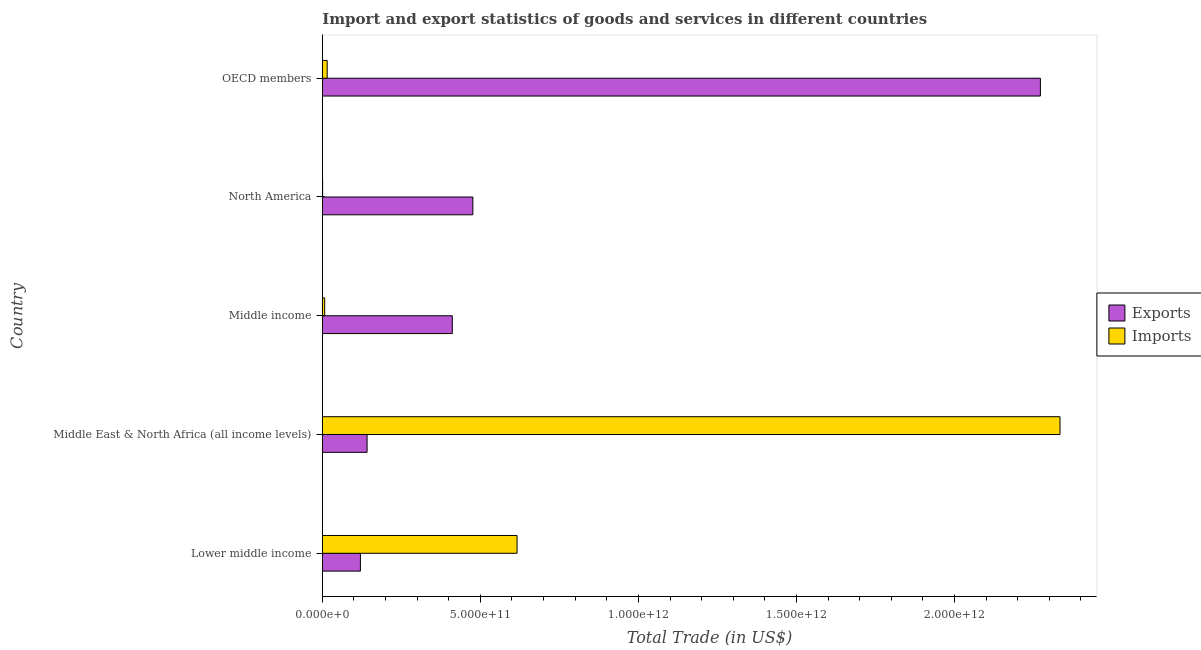How many groups of bars are there?
Give a very brief answer. 5. Are the number of bars per tick equal to the number of legend labels?
Offer a very short reply. Yes. Are the number of bars on each tick of the Y-axis equal?
Offer a terse response. Yes. How many bars are there on the 2nd tick from the top?
Ensure brevity in your answer.  2. What is the label of the 4th group of bars from the top?
Give a very brief answer. Middle East & North Africa (all income levels). In how many cases, is the number of bars for a given country not equal to the number of legend labels?
Provide a short and direct response. 0. What is the export of goods and services in Lower middle income?
Offer a very short reply. 1.20e+11. Across all countries, what is the maximum export of goods and services?
Offer a terse response. 2.27e+12. Across all countries, what is the minimum export of goods and services?
Provide a short and direct response. 1.20e+11. In which country was the export of goods and services maximum?
Provide a short and direct response. OECD members. What is the total imports of goods and services in the graph?
Offer a terse response. 2.97e+12. What is the difference between the imports of goods and services in Middle East & North Africa (all income levels) and that in OECD members?
Give a very brief answer. 2.32e+12. What is the difference between the imports of goods and services in OECD members and the export of goods and services in North America?
Give a very brief answer. -4.61e+11. What is the average export of goods and services per country?
Provide a succinct answer. 6.84e+11. What is the difference between the imports of goods and services and export of goods and services in Lower middle income?
Offer a very short reply. 4.96e+11. In how many countries, is the imports of goods and services greater than 800000000000 US$?
Make the answer very short. 1. What is the ratio of the export of goods and services in Middle East & North Africa (all income levels) to that in Middle income?
Your response must be concise. 0.34. Is the imports of goods and services in Middle East & North Africa (all income levels) less than that in North America?
Offer a terse response. No. What is the difference between the highest and the second highest export of goods and services?
Make the answer very short. 1.80e+12. What is the difference between the highest and the lowest imports of goods and services?
Ensure brevity in your answer.  2.33e+12. In how many countries, is the export of goods and services greater than the average export of goods and services taken over all countries?
Offer a very short reply. 1. Is the sum of the export of goods and services in Middle income and North America greater than the maximum imports of goods and services across all countries?
Provide a succinct answer. No. What does the 1st bar from the top in OECD members represents?
Offer a very short reply. Imports. What does the 1st bar from the bottom in Lower middle income represents?
Ensure brevity in your answer.  Exports. Are all the bars in the graph horizontal?
Offer a very short reply. Yes. How many countries are there in the graph?
Provide a succinct answer. 5. What is the difference between two consecutive major ticks on the X-axis?
Your answer should be compact. 5.00e+11. Does the graph contain grids?
Make the answer very short. No. How many legend labels are there?
Your answer should be very brief. 2. How are the legend labels stacked?
Keep it short and to the point. Vertical. What is the title of the graph?
Offer a terse response. Import and export statistics of goods and services in different countries. What is the label or title of the X-axis?
Your answer should be very brief. Total Trade (in US$). What is the Total Trade (in US$) of Exports in Lower middle income?
Your response must be concise. 1.20e+11. What is the Total Trade (in US$) of Imports in Lower middle income?
Provide a short and direct response. 6.16e+11. What is the Total Trade (in US$) of Exports in Middle East & North Africa (all income levels)?
Your answer should be very brief. 1.42e+11. What is the Total Trade (in US$) in Imports in Middle East & North Africa (all income levels)?
Provide a succinct answer. 2.33e+12. What is the Total Trade (in US$) of Exports in Middle income?
Give a very brief answer. 4.11e+11. What is the Total Trade (in US$) of Imports in Middle income?
Make the answer very short. 7.46e+09. What is the Total Trade (in US$) in Exports in North America?
Your answer should be very brief. 4.76e+11. What is the Total Trade (in US$) of Imports in North America?
Your answer should be very brief. 9.44e+08. What is the Total Trade (in US$) of Exports in OECD members?
Provide a short and direct response. 2.27e+12. What is the Total Trade (in US$) in Imports in OECD members?
Your answer should be compact. 1.54e+1. Across all countries, what is the maximum Total Trade (in US$) of Exports?
Provide a short and direct response. 2.27e+12. Across all countries, what is the maximum Total Trade (in US$) of Imports?
Your answer should be compact. 2.33e+12. Across all countries, what is the minimum Total Trade (in US$) of Exports?
Provide a short and direct response. 1.20e+11. Across all countries, what is the minimum Total Trade (in US$) in Imports?
Offer a very short reply. 9.44e+08. What is the total Total Trade (in US$) in Exports in the graph?
Give a very brief answer. 3.42e+12. What is the total Total Trade (in US$) of Imports in the graph?
Your answer should be compact. 2.97e+12. What is the difference between the Total Trade (in US$) of Exports in Lower middle income and that in Middle East & North Africa (all income levels)?
Provide a succinct answer. -2.11e+1. What is the difference between the Total Trade (in US$) of Imports in Lower middle income and that in Middle East & North Africa (all income levels)?
Give a very brief answer. -1.72e+12. What is the difference between the Total Trade (in US$) of Exports in Lower middle income and that in Middle income?
Give a very brief answer. -2.91e+11. What is the difference between the Total Trade (in US$) in Imports in Lower middle income and that in Middle income?
Offer a terse response. 6.09e+11. What is the difference between the Total Trade (in US$) of Exports in Lower middle income and that in North America?
Provide a short and direct response. -3.56e+11. What is the difference between the Total Trade (in US$) in Imports in Lower middle income and that in North America?
Give a very brief answer. 6.15e+11. What is the difference between the Total Trade (in US$) of Exports in Lower middle income and that in OECD members?
Give a very brief answer. -2.15e+12. What is the difference between the Total Trade (in US$) in Imports in Lower middle income and that in OECD members?
Offer a terse response. 6.01e+11. What is the difference between the Total Trade (in US$) in Exports in Middle East & North Africa (all income levels) and that in Middle income?
Provide a short and direct response. -2.70e+11. What is the difference between the Total Trade (in US$) of Imports in Middle East & North Africa (all income levels) and that in Middle income?
Keep it short and to the point. 2.33e+12. What is the difference between the Total Trade (in US$) of Exports in Middle East & North Africa (all income levels) and that in North America?
Provide a succinct answer. -3.35e+11. What is the difference between the Total Trade (in US$) of Imports in Middle East & North Africa (all income levels) and that in North America?
Your answer should be compact. 2.33e+12. What is the difference between the Total Trade (in US$) of Exports in Middle East & North Africa (all income levels) and that in OECD members?
Provide a succinct answer. -2.13e+12. What is the difference between the Total Trade (in US$) of Imports in Middle East & North Africa (all income levels) and that in OECD members?
Offer a terse response. 2.32e+12. What is the difference between the Total Trade (in US$) of Exports in Middle income and that in North America?
Your response must be concise. -6.50e+1. What is the difference between the Total Trade (in US$) of Imports in Middle income and that in North America?
Provide a short and direct response. 6.51e+09. What is the difference between the Total Trade (in US$) in Exports in Middle income and that in OECD members?
Keep it short and to the point. -1.86e+12. What is the difference between the Total Trade (in US$) in Imports in Middle income and that in OECD members?
Give a very brief answer. -7.94e+09. What is the difference between the Total Trade (in US$) in Exports in North America and that in OECD members?
Your response must be concise. -1.80e+12. What is the difference between the Total Trade (in US$) of Imports in North America and that in OECD members?
Offer a terse response. -1.45e+1. What is the difference between the Total Trade (in US$) in Exports in Lower middle income and the Total Trade (in US$) in Imports in Middle East & North Africa (all income levels)?
Offer a terse response. -2.21e+12. What is the difference between the Total Trade (in US$) of Exports in Lower middle income and the Total Trade (in US$) of Imports in Middle income?
Your answer should be compact. 1.13e+11. What is the difference between the Total Trade (in US$) in Exports in Lower middle income and the Total Trade (in US$) in Imports in North America?
Provide a short and direct response. 1.20e+11. What is the difference between the Total Trade (in US$) of Exports in Lower middle income and the Total Trade (in US$) of Imports in OECD members?
Offer a very short reply. 1.05e+11. What is the difference between the Total Trade (in US$) in Exports in Middle East & North Africa (all income levels) and the Total Trade (in US$) in Imports in Middle income?
Provide a succinct answer. 1.34e+11. What is the difference between the Total Trade (in US$) in Exports in Middle East & North Africa (all income levels) and the Total Trade (in US$) in Imports in North America?
Offer a terse response. 1.41e+11. What is the difference between the Total Trade (in US$) of Exports in Middle East & North Africa (all income levels) and the Total Trade (in US$) of Imports in OECD members?
Provide a succinct answer. 1.26e+11. What is the difference between the Total Trade (in US$) in Exports in Middle income and the Total Trade (in US$) in Imports in North America?
Offer a very short reply. 4.10e+11. What is the difference between the Total Trade (in US$) of Exports in Middle income and the Total Trade (in US$) of Imports in OECD members?
Give a very brief answer. 3.96e+11. What is the difference between the Total Trade (in US$) in Exports in North America and the Total Trade (in US$) in Imports in OECD members?
Make the answer very short. 4.61e+11. What is the average Total Trade (in US$) of Exports per country?
Your answer should be very brief. 6.84e+11. What is the average Total Trade (in US$) of Imports per country?
Your answer should be compact. 5.95e+11. What is the difference between the Total Trade (in US$) in Exports and Total Trade (in US$) in Imports in Lower middle income?
Offer a terse response. -4.96e+11. What is the difference between the Total Trade (in US$) in Exports and Total Trade (in US$) in Imports in Middle East & North Africa (all income levels)?
Provide a short and direct response. -2.19e+12. What is the difference between the Total Trade (in US$) of Exports and Total Trade (in US$) of Imports in Middle income?
Provide a succinct answer. 4.04e+11. What is the difference between the Total Trade (in US$) in Exports and Total Trade (in US$) in Imports in North America?
Provide a short and direct response. 4.75e+11. What is the difference between the Total Trade (in US$) of Exports and Total Trade (in US$) of Imports in OECD members?
Make the answer very short. 2.26e+12. What is the ratio of the Total Trade (in US$) in Exports in Lower middle income to that in Middle East & North Africa (all income levels)?
Ensure brevity in your answer.  0.85. What is the ratio of the Total Trade (in US$) in Imports in Lower middle income to that in Middle East & North Africa (all income levels)?
Offer a terse response. 0.26. What is the ratio of the Total Trade (in US$) in Exports in Lower middle income to that in Middle income?
Provide a short and direct response. 0.29. What is the ratio of the Total Trade (in US$) of Imports in Lower middle income to that in Middle income?
Make the answer very short. 82.6. What is the ratio of the Total Trade (in US$) in Exports in Lower middle income to that in North America?
Provide a succinct answer. 0.25. What is the ratio of the Total Trade (in US$) in Imports in Lower middle income to that in North America?
Your response must be concise. 652.49. What is the ratio of the Total Trade (in US$) in Exports in Lower middle income to that in OECD members?
Offer a terse response. 0.05. What is the ratio of the Total Trade (in US$) of Imports in Lower middle income to that in OECD members?
Provide a short and direct response. 40.02. What is the ratio of the Total Trade (in US$) in Exports in Middle East & North Africa (all income levels) to that in Middle income?
Provide a short and direct response. 0.34. What is the ratio of the Total Trade (in US$) in Imports in Middle East & North Africa (all income levels) to that in Middle income?
Provide a succinct answer. 312.91. What is the ratio of the Total Trade (in US$) in Exports in Middle East & North Africa (all income levels) to that in North America?
Your answer should be compact. 0.3. What is the ratio of the Total Trade (in US$) in Imports in Middle East & North Africa (all income levels) to that in North America?
Offer a very short reply. 2471.65. What is the ratio of the Total Trade (in US$) in Exports in Middle East & North Africa (all income levels) to that in OECD members?
Your response must be concise. 0.06. What is the ratio of the Total Trade (in US$) of Imports in Middle East & North Africa (all income levels) to that in OECD members?
Offer a very short reply. 151.58. What is the ratio of the Total Trade (in US$) in Exports in Middle income to that in North America?
Provide a short and direct response. 0.86. What is the ratio of the Total Trade (in US$) in Imports in Middle income to that in North America?
Your response must be concise. 7.9. What is the ratio of the Total Trade (in US$) of Exports in Middle income to that in OECD members?
Provide a succinct answer. 0.18. What is the ratio of the Total Trade (in US$) in Imports in Middle income to that in OECD members?
Your answer should be very brief. 0.48. What is the ratio of the Total Trade (in US$) of Exports in North America to that in OECD members?
Offer a terse response. 0.21. What is the ratio of the Total Trade (in US$) in Imports in North America to that in OECD members?
Keep it short and to the point. 0.06. What is the difference between the highest and the second highest Total Trade (in US$) of Exports?
Your answer should be compact. 1.80e+12. What is the difference between the highest and the second highest Total Trade (in US$) of Imports?
Your response must be concise. 1.72e+12. What is the difference between the highest and the lowest Total Trade (in US$) of Exports?
Offer a very short reply. 2.15e+12. What is the difference between the highest and the lowest Total Trade (in US$) in Imports?
Offer a terse response. 2.33e+12. 